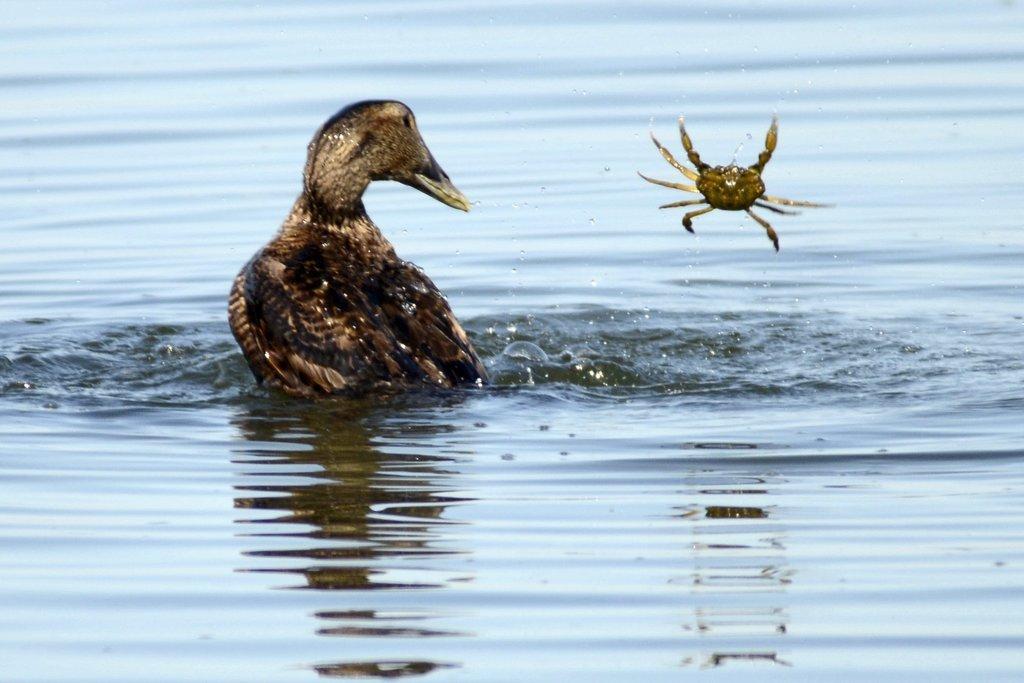In one or two sentences, can you explain what this image depicts? In this image in the center there is one bird, at the bottom there is a river and also there is one crab in the air. 